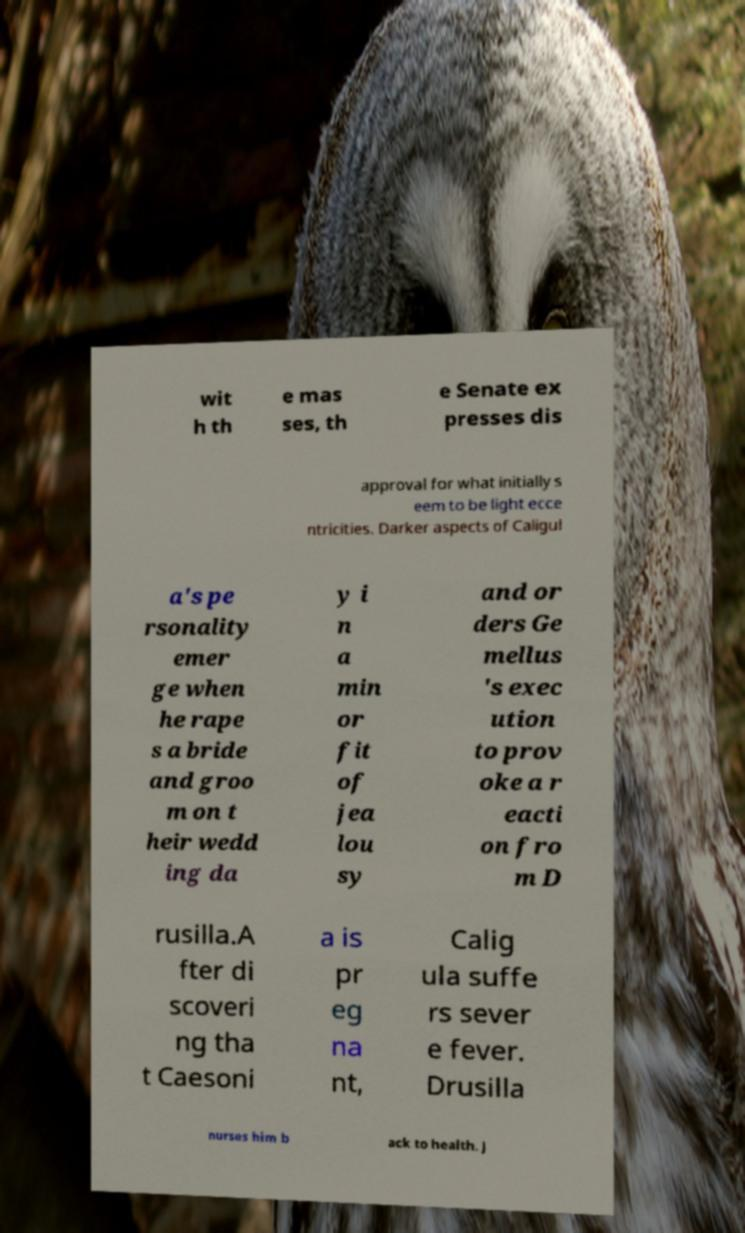Could you assist in decoding the text presented in this image and type it out clearly? wit h th e mas ses, th e Senate ex presses dis approval for what initially s eem to be light ecce ntricities. Darker aspects of Caligul a's pe rsonality emer ge when he rape s a bride and groo m on t heir wedd ing da y i n a min or fit of jea lou sy and or ders Ge mellus 's exec ution to prov oke a r eacti on fro m D rusilla.A fter di scoveri ng tha t Caesoni a is pr eg na nt, Calig ula suffe rs sever e fever. Drusilla nurses him b ack to health. J 